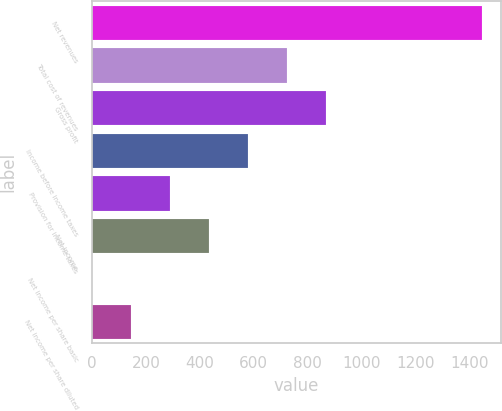Convert chart. <chart><loc_0><loc_0><loc_500><loc_500><bar_chart><fcel>Net revenues<fcel>Total cost of revenues<fcel>Gross profit<fcel>Income before income taxes<fcel>Provision for income taxes<fcel>Net income<fcel>Net income per share basic<fcel>Net income per share diluted<nl><fcel>1444.6<fcel>722.37<fcel>866.81<fcel>577.93<fcel>289.05<fcel>433.49<fcel>0.17<fcel>144.61<nl></chart> 